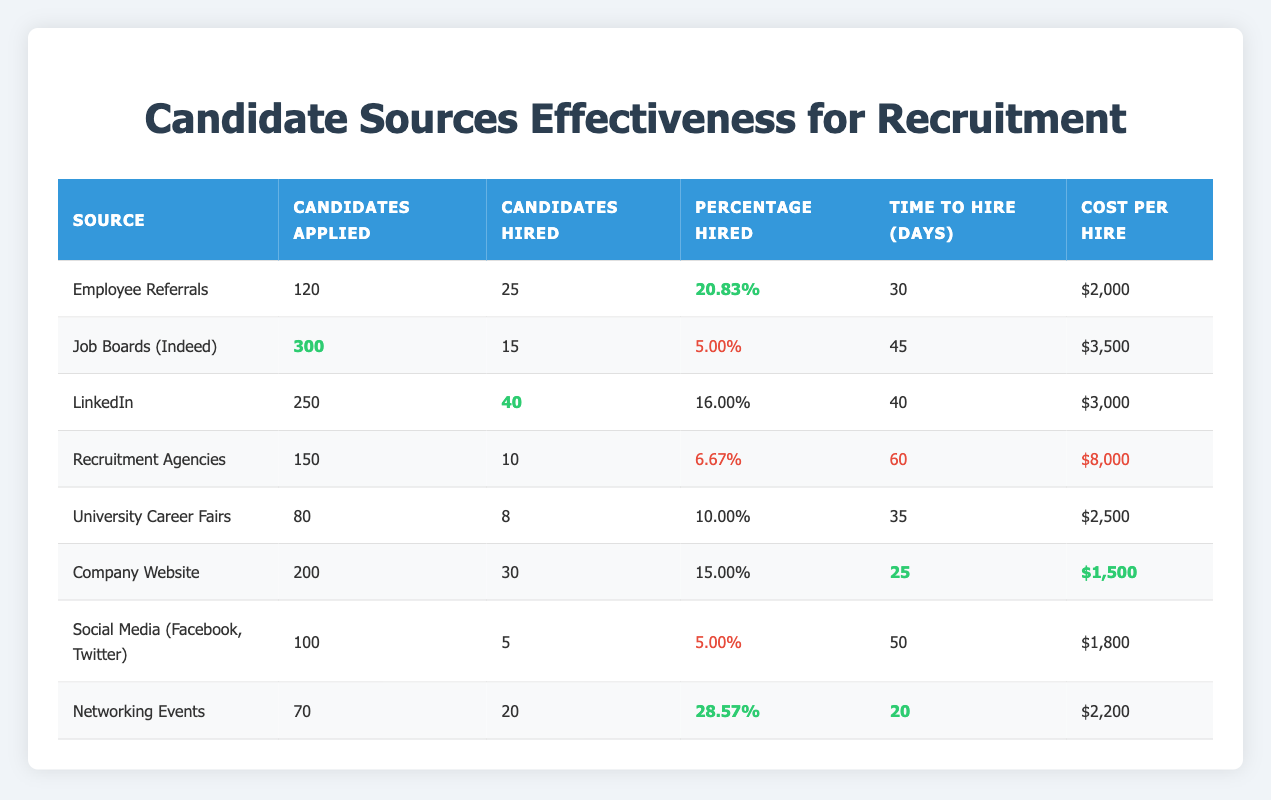What source had the highest percentage of candidates hired? The highest percentage of candidates hired can be found by comparing the "Percentage Hired" column. The highest percentage is 28.57% from Networking Events.
Answer: Networking Events How many candidates were hired from Employee Referrals? Looking at the "Candidates Hired" column for Employee Referrals, it shows 25 candidates were hired.
Answer: 25 What is the cost of hiring candidates from Recruitment Agencies? The "Cost Per Hire" for Recruitment Agencies is listed as $8,000.
Answer: $8,000 How many total candidates applied from Job Boards (Indeed) and LinkedIn? By adding the "Candidates Applied" values for Job Boards (Indeed) and LinkedIn, we have 300 + 250 = 550 candidates applied.
Answer: 550 Which source had the shortest time to hire? The shortest "Time to Hire" can be determined by examining the respective times, with Networking Events at 20 days noted as the lowest.
Answer: Networking Events Is the percentage hired from Social Media higher than that from University Career Fairs? Comparing the "Percentage Hired" for Social Media (5.00%) and University Career Fairs (10.00%), Social Media's percentage is lower.
Answer: No What is the average cost per hire for the top three sources ranked by percentage hired? The top three sources by "Percentage Hired" are Networking Events (28.57%), Employee Referrals (20.83%), and LinkedIn (16.00%). The costs are $2,200, $2,000, and $3,000, respectively. The total cost is $2,200 + $2,000 + $3,000 = $7,200, divided by 3 gives an average of $2,400.
Answer: $2,400 If all candidates hired from Company Website were directly compared to those hired from Job Boards (Indeed), how many more candidates were hired? Comparing the "Candidates Hired" from Company Website (30) and Job Boards (Indeed) (15), we find 30 - 15 = 15 more candidates were hired from Company Website.
Answer: 15 What is the total number of candidates applied across all sources? Summing all "Candidates Applied" values: 120 + 300 + 250 + 150 + 80 + 200 + 100 + 70 gives 1,270 candidates applied in total.
Answer: 1,270 Which recruitment source costs less than $2,500 per hire? By checking the "Cost Per Hire" column, those below $2,500 are Company Website ($1,500) and Social Media ($1,800).
Answer: Company Website and Social Media What is the percentage hired across all sources that had a hiring percentage below 10%? The sources with hiring percentages below 10% are Job Boards (5.00%), Recruitment Agencies (6.67%), and Social Media (5.00%). Adding these: 5.00 + 6.67 + 5.00 = 16.67%. Dividing by 3 gives an average of 5.56%.
Answer: 5.56% 